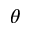Convert formula to latex. <formula><loc_0><loc_0><loc_500><loc_500>\theta</formula> 